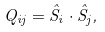<formula> <loc_0><loc_0><loc_500><loc_500>Q _ { i j } = \hat { S } _ { i } \cdot \hat { S } _ { j } ,</formula> 